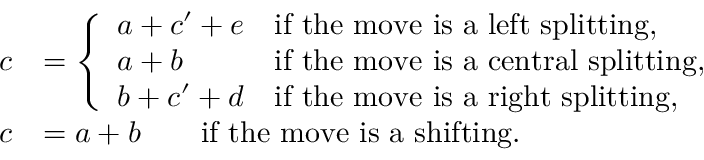Convert formula to latex. <formula><loc_0><loc_0><loc_500><loc_500>\begin{array} { r l } { c } & { = \left \{ \begin{array} { l l } { a + c ^ { \prime } + e } & { i f t h e m o v e i s a l e f t s p l i t t i n g , } \\ { a + b } & { i f t h e m o v e i s a c e n t r a l s p l i t t i n g , } \\ { b + c ^ { \prime } + d } & { i f t h e m o v e i s a r i g h t s p l i t t i n g , } \end{array} } \\ { c } & { = a + b \quad i f t h e m o v e i s a s h i f t i n g . } \end{array}</formula> 